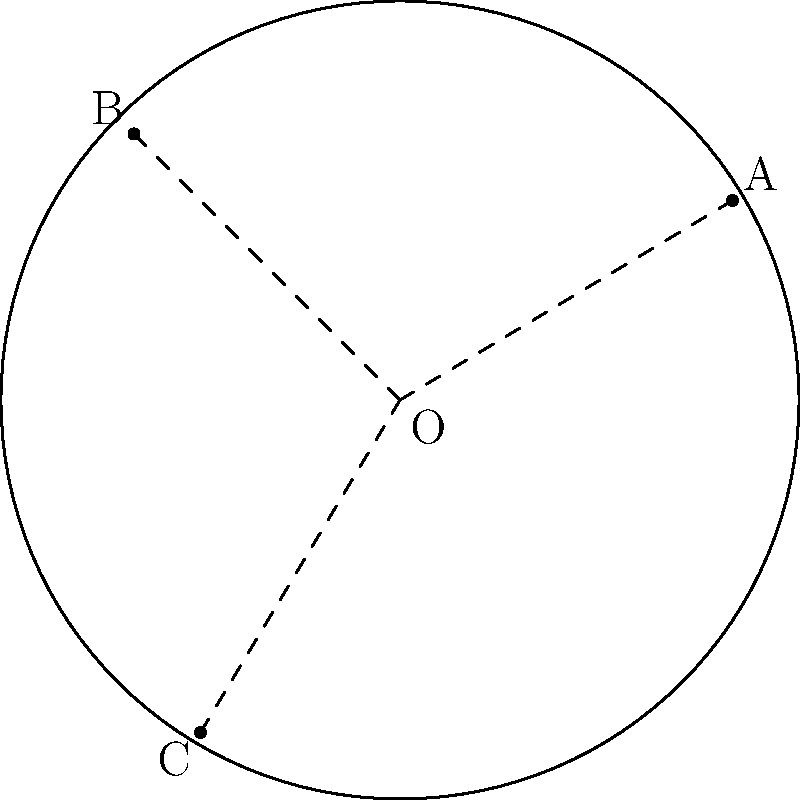In a circular study area of radius 3 units, three poaching hotspots A, B, and C have been identified. If the distances of these hotspots from the center O are in the ratio 2:3:4, and the angle BOC is 120°, what is the area of triangle ABC? Let's approach this step-by-step:

1) Let's denote the radius of the circle as r = 3 units.

2) Given the ratio of distances from O, we can say:
   OA : OB : OC = 2 : 3 : 4
   
3) Let's say OA = 2x, OB = 3x, and OC = 4x

4) We know that OC is a radius, so:
   4x = r = 3
   x = 3/4 = 0.75

5) Now we can calculate:
   OA = 2(0.75) = 1.5
   OB = 3(0.75) = 2.25
   OC = 4(0.75) = 3

6) We're given that angle BOC = 120°. Let's call this angle θ.

7) We can use the formula for the area of a triangle given two sides and the included angle:
   Area = $\frac{1}{2}$ * OB * OC * sin(θ)

8) Substituting the values:
   Area = $\frac{1}{2}$ * 2.25 * 3 * sin(120°)

9) sin(120°) = $\frac{\sqrt{3}}{2}$

10) Therefore:
    Area = $\frac{1}{2}$ * 2.25 * 3 * $\frac{\sqrt{3}}{2}$
         = $\frac{27\sqrt{3}}{8}$ ≈ 5.85 square units
Answer: $\frac{27\sqrt{3}}{8}$ square units 